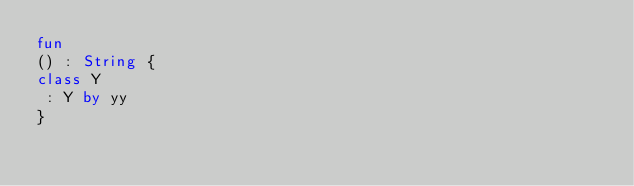Convert code to text. <code><loc_0><loc_0><loc_500><loc_500><_Kotlin_>fun 
() : String {
class Y
 : Y by yy
}</code> 